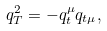Convert formula to latex. <formula><loc_0><loc_0><loc_500><loc_500>q _ { T } ^ { 2 } = - q _ { t } ^ { \mu } q _ { t \mu } ,</formula> 